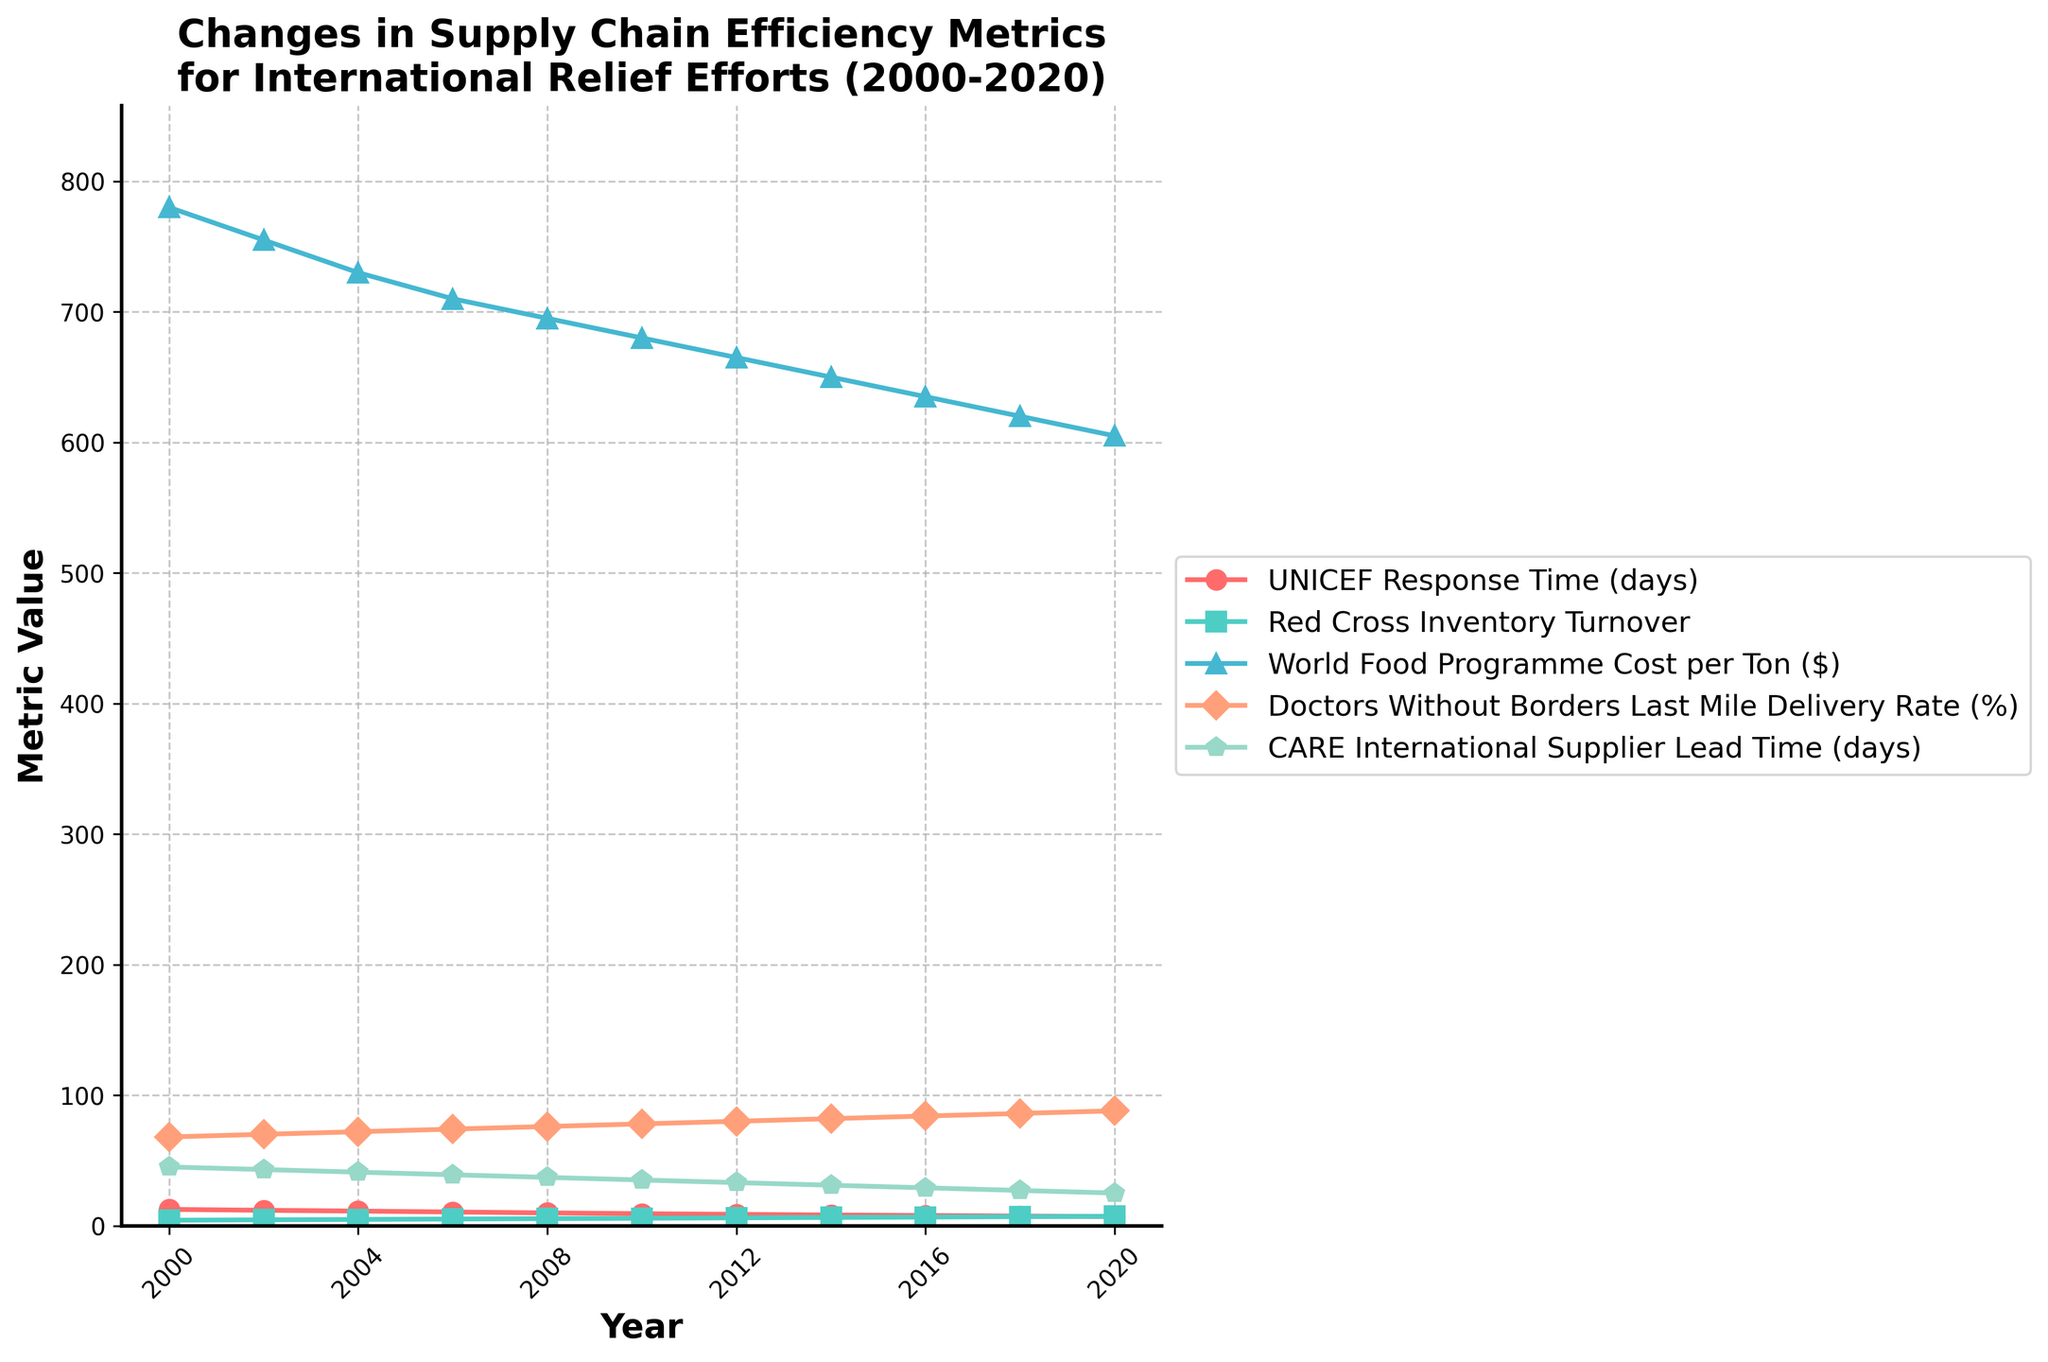What is the general trend of UNICEF Response Time from 2000 to 2020? The plot shows a line representing UNICEF Response Time. From 2000 to 2020, the line steadily declines, indicating a reduction in response time.
Answer: Decreasing Which metric shows the most significant improvement in efficiency based on the steepest decline from 2000 to 2020? The line representing the metric with the steepest decline shows the most significant improvement in efficiency. Comparing the lines, UNICEF Response Time has the most significant decrease.
Answer: UNICEF Response Time Compare the Inventory Turnover of Red Cross in 2000 and 2020. What is the percentage increase? In 2000, Red Cross Inventory Turnover is 4.2, and in 2020, it is 7.2. The percentage increase is calculated as ((7.2 - 4.2) / 4.2) * 100.
Answer: 71.43% How does the Last Mile Delivery Rate of Doctors Without Borders in 2006 compare to that in 2020? The Last Mile Delivery Rate in 2006 is represented by the line with markers. It starts at 74% in 2006 and rises to 88% in 2020. A simple difference calculation shows the increase.
Answer: Increased by 14% Which organization experienced the highest decrease in Supplier Lead Time from 2000 to 2020? Look for the line representing Supplier Lead Time, which is for CARE International. From 45 days in 2000 to 25 days in 2020, CARE International shows the highest decrease in lead time.
Answer: CARE International What is the average Inventory Turnover of the Red Cross from 2000 to 2020? Sum all Inventory Turnover values for Red Cross from the plot's data points: 4.2 + 4.5 + 4.8 + 5.1 + 5.4 + 5.7 + 6.0 + 6.3 + 6.6 + 6.9 + 7.2. Divide this sum by the number of years (11).
Answer: 5.67 By how much did the Cost per Ton for the World Food Programme change between 2002 and 2018? Look at the line representing World Food Programme Cost per Ton. In 2002, it was 755$, and in 2018, it was 620$. The change is 755 - 620 = 135$.
Answer: 135$ decrease Which year did UNICEF Response Time drop below 10 days? The line for UNICEF Response Time shows that it drops below 10 days between 2006 and 2008. By verifying, it drops to 9.8 days in 2008.
Answer: 2008 What is the average decline rate per year of UNICEF Response Time over the two decades? The rate of decline is given by (initial value - final value) / time period. For UNICEF Response Time, this is (12.5 - 7.0) / 20.
Answer: 0.275 days per year How does the trend in Doctor Without Borders' Last Mile Delivery Rate correlate with CARE International's Supplier Lead Time trend? Examine the line trends of both metrics. Doctors Without Borders shows a consistent increase while CARE International shows a consistent decrease, showing an inverse correlation.
Answer: Inverse correlation 